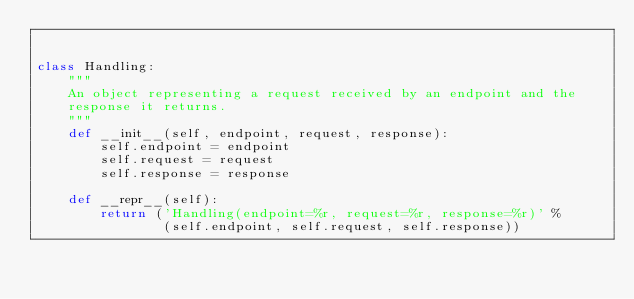<code> <loc_0><loc_0><loc_500><loc_500><_Python_>

class Handling:
    """
    An object representing a request received by an endpoint and the
    response it returns.
    """
    def __init__(self, endpoint, request, response):
        self.endpoint = endpoint
        self.request = request
        self.response = response

    def __repr__(self):
        return ('Handling(endpoint=%r, request=%r, response=%r)' %
                (self.endpoint, self.request, self.response))
</code> 